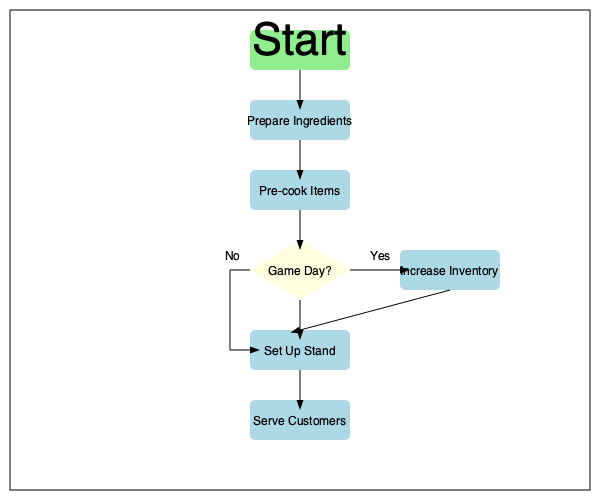Analyze the given flowchart for a street food vendor's workflow. If the vendor wants to optimize their process for game days, which step should they focus on improving to maximize efficiency and customer satisfaction? Explain your reasoning and propose a specific enhancement to this step. To optimize the process for game days and maximize efficiency and customer satisfaction, we should analyze each step in the flowchart:

1. Start: This is the beginning of the process and cannot be optimized further.

2. Prepare Ingredients: This step is crucial but occurs before knowing if it's a game day.

3. Pre-cook Items: Similar to step 2, this happens before the game day decision.

4. Game Day? This is the decision point that leads to the key difference in the workflow.

5. Increase Inventory: This step only occurs on game days and is directly related to meeting increased demand.

6. Set Up Stand: This step is necessary regardless of whether it's a game day.

7. Serve Customers: This is the final step where the vendor interacts with customers.

The most critical step to focus on for game days is "Increase Inventory." Here's why:

1. It's the only step that specifically addresses the unique challenges of game days.
2. Proper inventory management is crucial for handling the increased customer volume during games.
3. Having the right amount of inventory can significantly impact both efficiency and customer satisfaction.

A specific enhancement to this step could be implementing a just-in-time (JIT) inventory system tailored for game days. This would involve:

1. Analyzing historical data from previous game days to predict demand accurately.
2. Establishing relationships with suppliers for rapid, last-minute deliveries.
3. Creating a modular menu that allows for quick adjustments based on available ingredients.
4. Implementing a real-time inventory tracking system to monitor stock levels throughout the game.

By focusing on and improving the "Increase Inventory" step, the vendor can ensure they have the right amount of ingredients and pre-cooked items to meet the high demand during games, reduce waste, and serve customers quickly and efficiently.
Answer: Increase Inventory step; implement a just-in-time (JIT) inventory system for game days. 